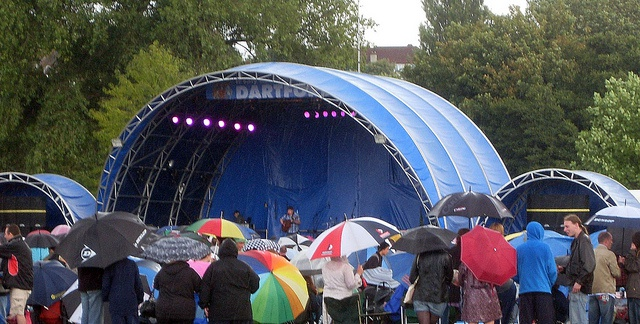Describe the objects in this image and their specific colors. I can see people in darkgreen, black, gray, darkgray, and navy tones, umbrella in darkgreen, black, and gray tones, people in darkgreen, black, blue, and gray tones, people in darkgreen, black, gray, and purple tones, and umbrella in darkgreen, green, khaki, and blue tones in this image. 